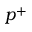<formula> <loc_0><loc_0><loc_500><loc_500>p ^ { + }</formula> 